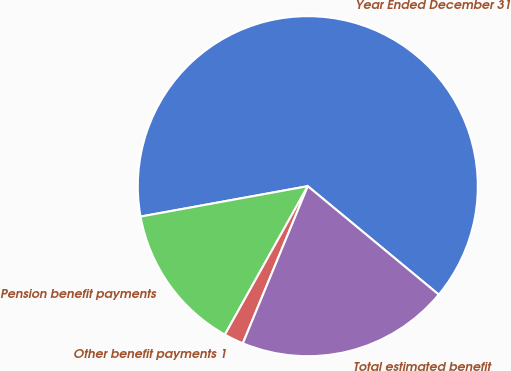Convert chart to OTSL. <chart><loc_0><loc_0><loc_500><loc_500><pie_chart><fcel>Year Ended December 31<fcel>Pension benefit payments<fcel>Other benefit payments 1<fcel>Total estimated benefit<nl><fcel>63.87%<fcel>14.03%<fcel>1.87%<fcel>20.23%<nl></chart> 